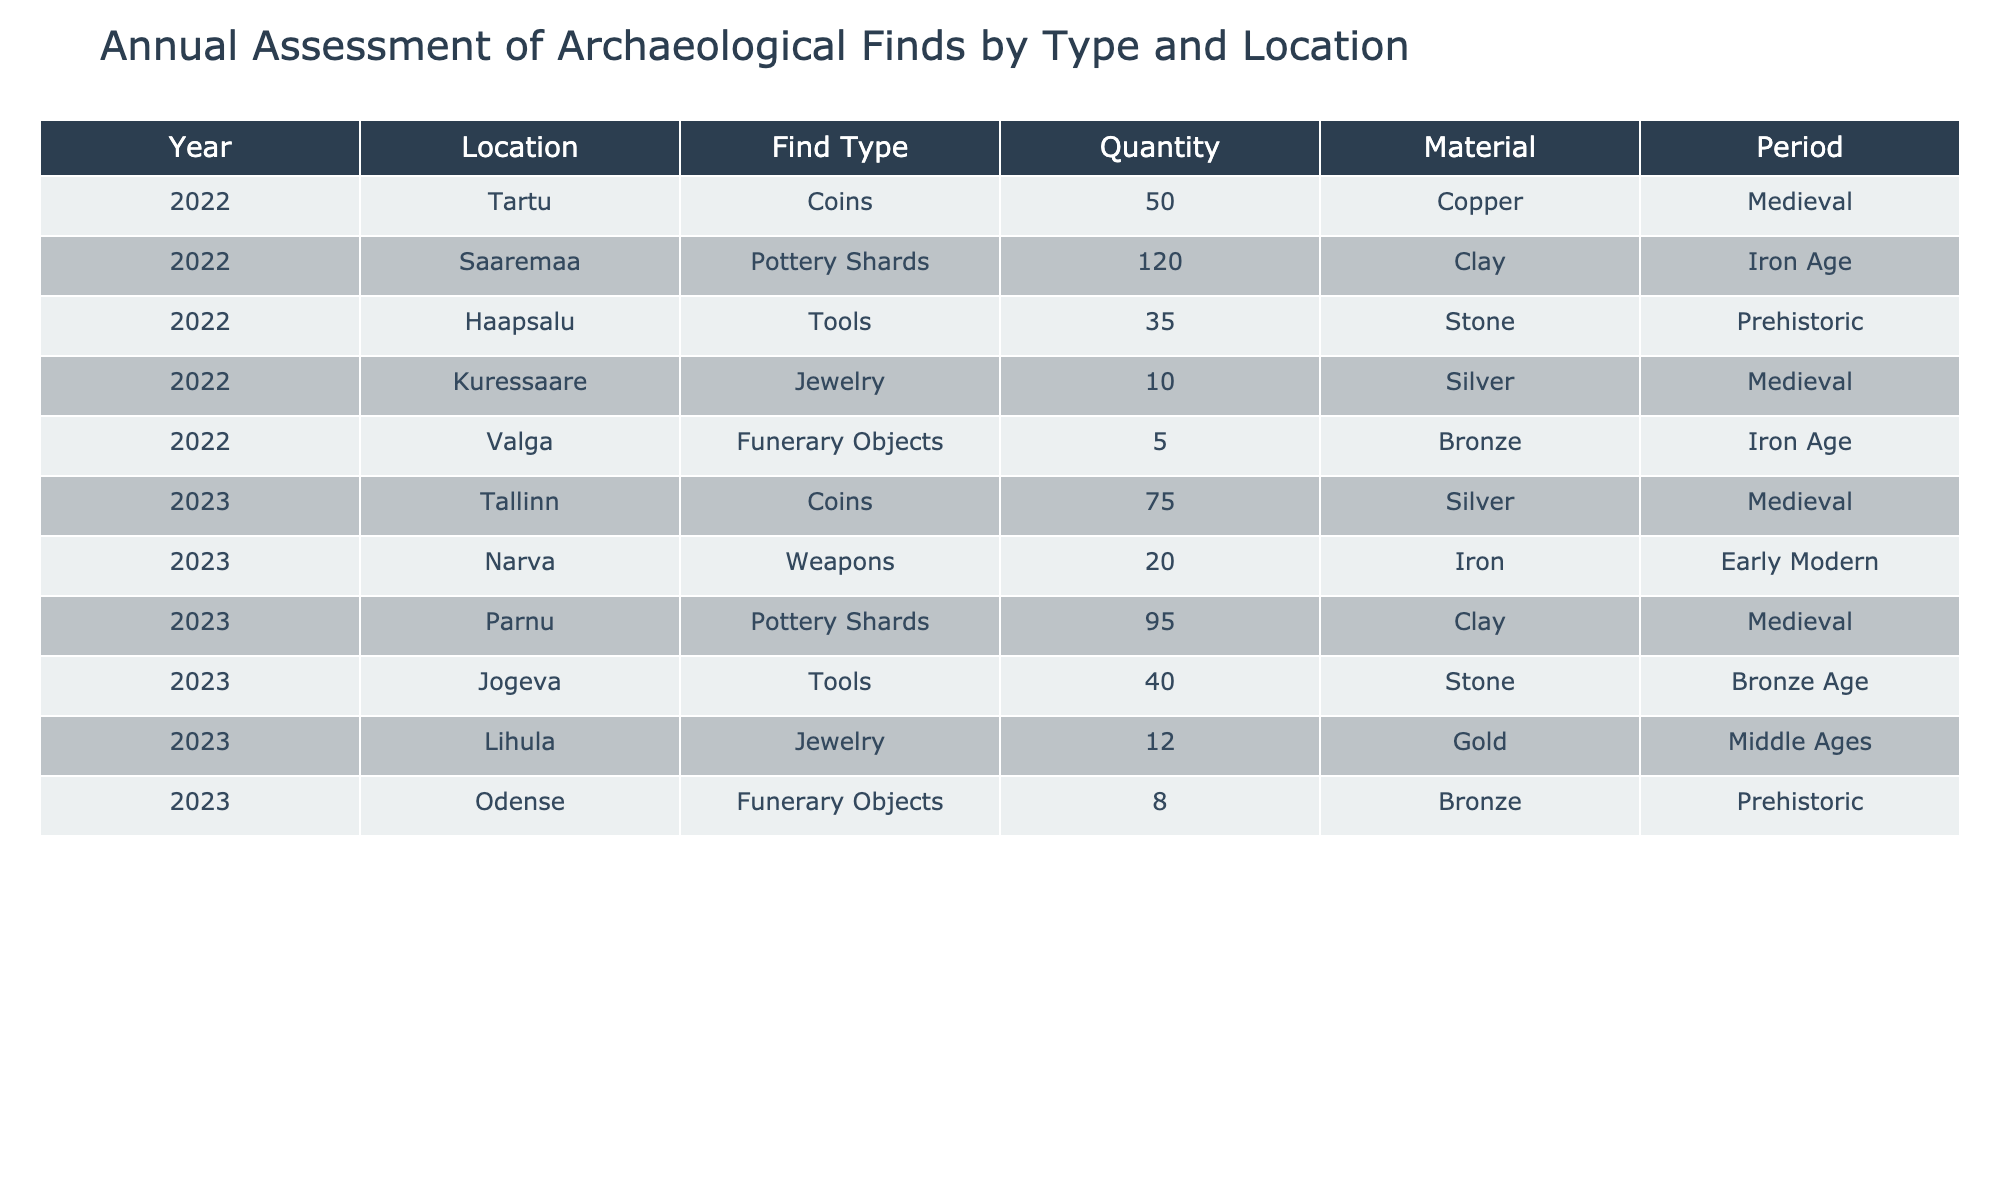What was the total quantity of Coins found in 2022? In 2022, the only entry for Coins is from Tartu, which reports a quantity of 50. Since this is the only data available for that year, the total quantity of Coins found in 2022 is simply 50.
Answer: 50 How many Pottery Shards were discovered in 2023 compared to 2022? In 2022, there were 120 Pottery Shards found in Saaremaa, and in 2023, there were 95 Pottery Shards found in Parnu. The difference is 120 - 95 = 25. So, 25 less Pottery Shards were discovered in 2023 compared to 2022.
Answer: 25 Did any Funerary Objects made of Bronze appear in 2022? The table shows that in 2022, Funerary Objects were found in Valga, and they were made of Bronze. Therefore, the answer is yes, there were Funerary Objects made of Bronze in 2022.
Answer: Yes What is the total quantity of Jewelry found over the two years? For the two years, the Jewelry quantities are 10 in Kuressaare (2022) and 12 in Lihula (2023). Adding these together gives 10 + 12 = 22. Therefore, the total quantity of Jewelry found over the two years is 22.
Answer: 22 Which location had the highest quantity of Tools found in 2023, and what was the amount? In 2023, Jogeva reported 40 Tools as the highest quantity in comparison to the 35 found in Haapsalu in 2022. Thus, Jogeva is the location with the highest quantity of Tools in 2023 with an amount of 40.
Answer: Jogeva, 40 What percentage of the total finds in 2023 were Funerary Objects? In 2023, the total finds were calculated as follows: Coins (75) + Weapons (20) + Pottery Shards (95) + Tools (40) + Jewelry (12) + Funerary Objects (8), which sums to 75 + 20 + 95 + 40 + 12 + 8 = 250. Funerary Objects constitute 8 out of 250, leading to a percentage of (8/250) * 100 = 3.2%.
Answer: 3.2% How many more Tools were found in 2022 compared to Funerary Objects in 2023? In 2022, 35 Tools were found in Haapsalu, and in 2023, 8 Funerary Objects were found in Odense. Subtracting these gives 35 - 8 = 27 more Tools found in 2022 compared to Funerary Objects in 2023.
Answer: 27 Were there any finds made of Gold, and if so, in which year and location? According to the table, there is one find made of Gold, which is Jewelry found in Lihula in 2023. So, the answer is Yes, there were finds made of Gold in 2023 at Lihula.
Answer: Yes 